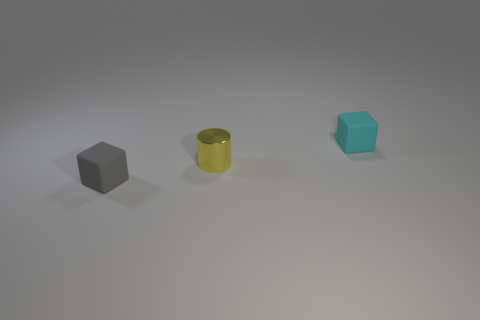Add 3 tiny blocks. How many objects exist? 6 Subtract all cubes. How many objects are left? 1 Subtract all blue metallic balls. Subtract all tiny cubes. How many objects are left? 1 Add 3 cylinders. How many cylinders are left? 4 Add 2 small rubber blocks. How many small rubber blocks exist? 4 Subtract 0 gray spheres. How many objects are left? 3 